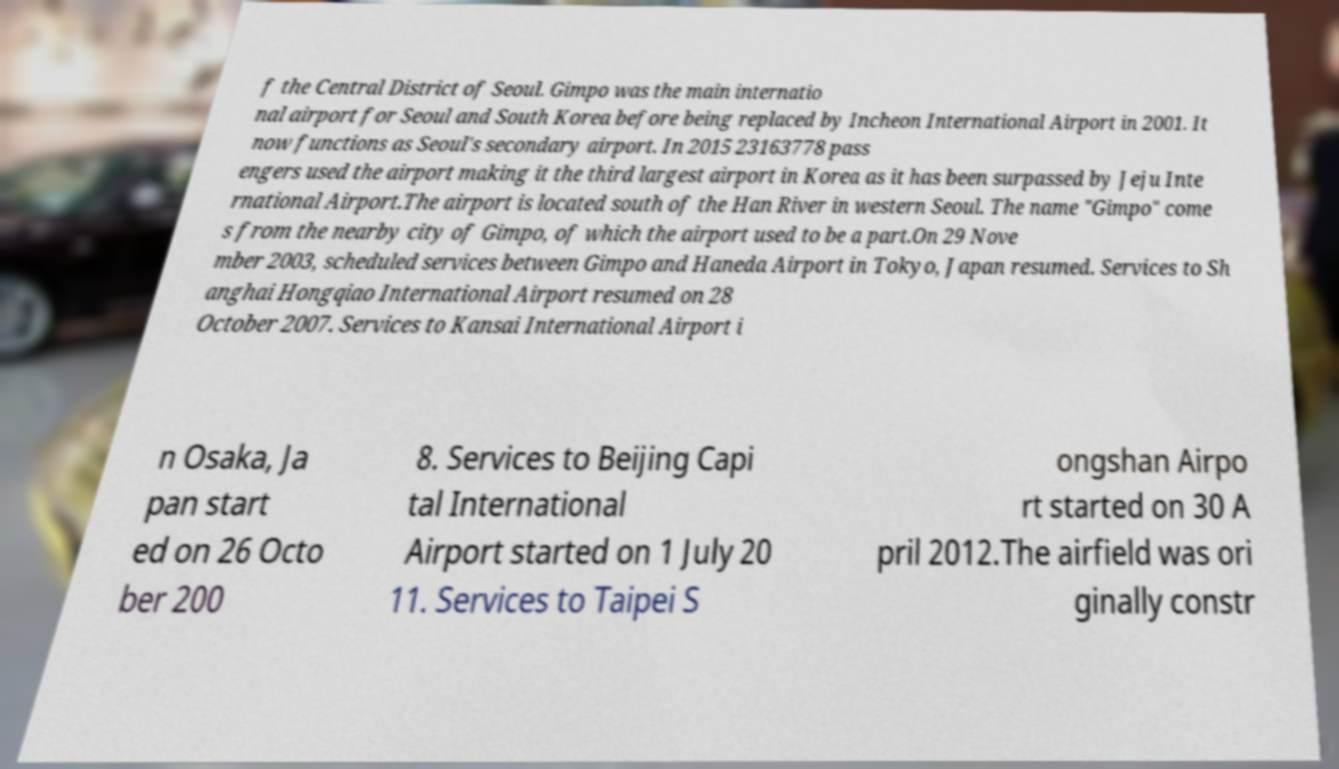There's text embedded in this image that I need extracted. Can you transcribe it verbatim? f the Central District of Seoul. Gimpo was the main internatio nal airport for Seoul and South Korea before being replaced by Incheon International Airport in 2001. It now functions as Seoul's secondary airport. In 2015 23163778 pass engers used the airport making it the third largest airport in Korea as it has been surpassed by Jeju Inte rnational Airport.The airport is located south of the Han River in western Seoul. The name "Gimpo" come s from the nearby city of Gimpo, of which the airport used to be a part.On 29 Nove mber 2003, scheduled services between Gimpo and Haneda Airport in Tokyo, Japan resumed. Services to Sh anghai Hongqiao International Airport resumed on 28 October 2007. Services to Kansai International Airport i n Osaka, Ja pan start ed on 26 Octo ber 200 8. Services to Beijing Capi tal International Airport started on 1 July 20 11. Services to Taipei S ongshan Airpo rt started on 30 A pril 2012.The airfield was ori ginally constr 